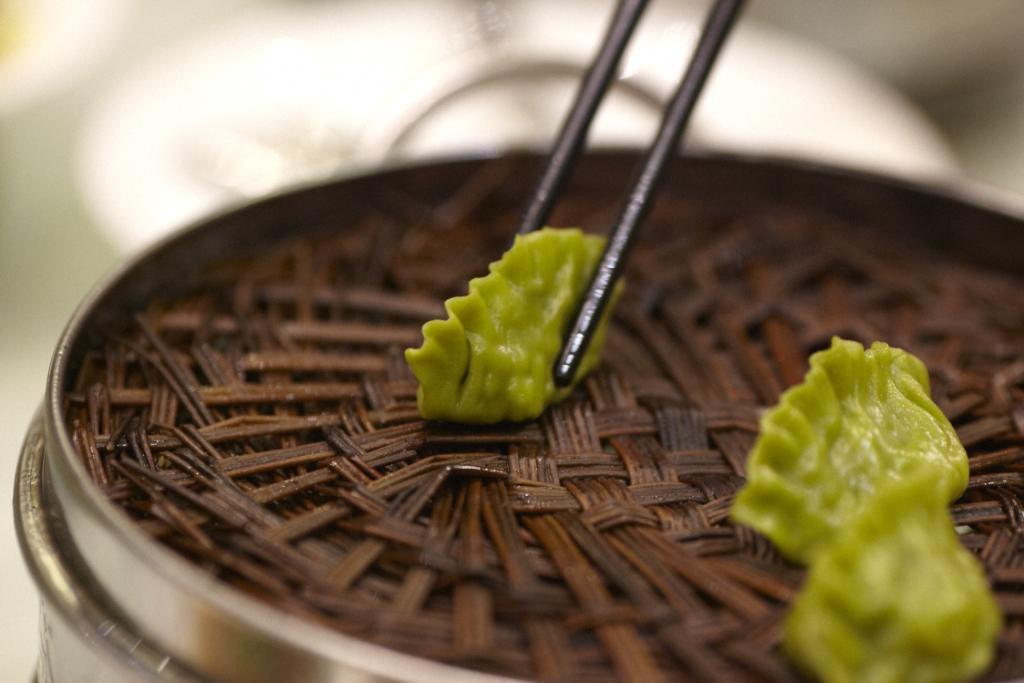What type of food is shown in the image? There are three green momos in the image. How are the momos being prepared or served? The momos are in a steamer. Are there any utensils visible in the image? Yes, one of the momos is held by brown chopsticks. What type of yam is being used to play baseball in the image? There is no yam or baseball present in the image; it features three green momos in a steamer. Where can you buy these momos in the image? The image does not show a store or any indication of where the momos can be purchased. 